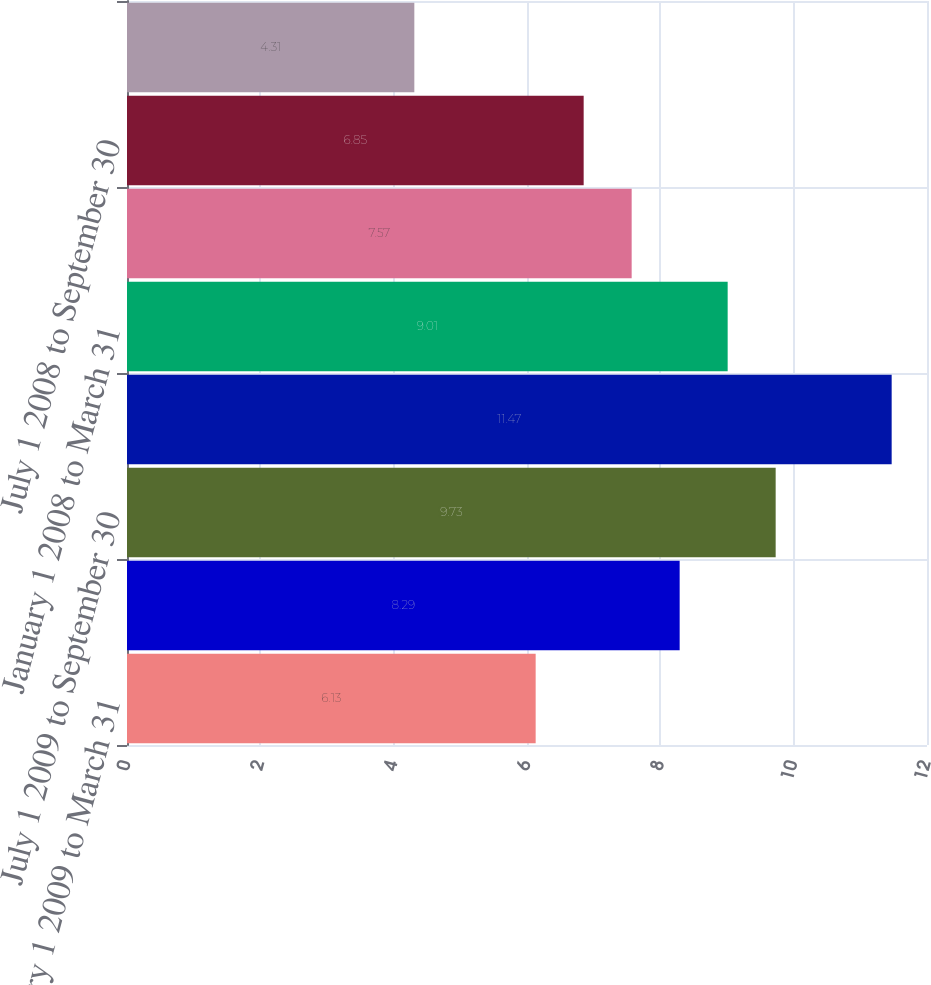<chart> <loc_0><loc_0><loc_500><loc_500><bar_chart><fcel>January 1 2009 to March 31<fcel>April 1 2009 to June 30 2009<fcel>July 1 2009 to September 30<fcel>October 1 2009 to December 31<fcel>January 1 2008 to March 31<fcel>April 1 2008 to June 30 2008<fcel>July 1 2008 to September 30<fcel>October 1 2008 to December 31<nl><fcel>6.13<fcel>8.29<fcel>9.73<fcel>11.47<fcel>9.01<fcel>7.57<fcel>6.85<fcel>4.31<nl></chart> 